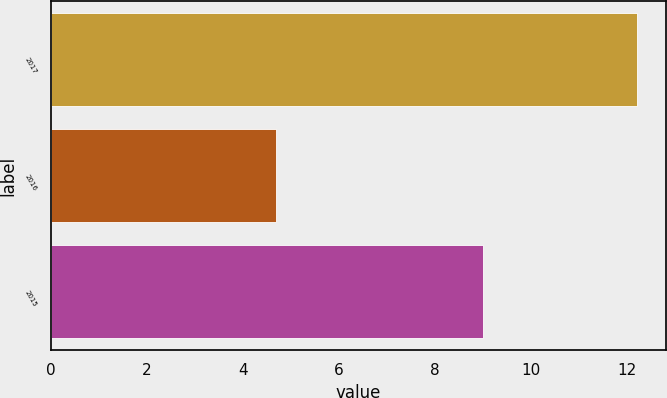Convert chart. <chart><loc_0><loc_0><loc_500><loc_500><bar_chart><fcel>2017<fcel>2016<fcel>2015<nl><fcel>12.2<fcel>4.7<fcel>9<nl></chart> 